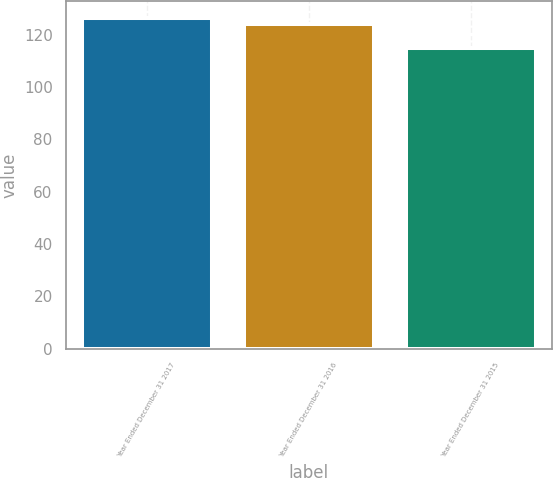Convert chart to OTSL. <chart><loc_0><loc_0><loc_500><loc_500><bar_chart><fcel>Year Ended December 31 2017<fcel>Year Ended December 31 2016<fcel>Year Ended December 31 2015<nl><fcel>126.44<fcel>124.01<fcel>114.9<nl></chart> 